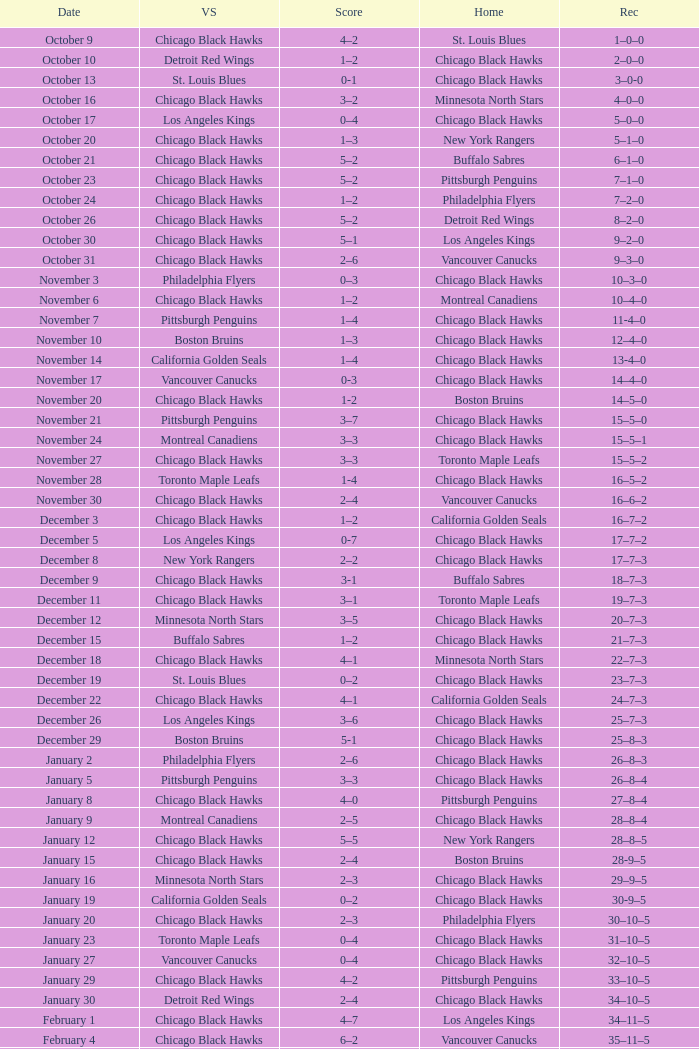What is the Record from February 10? 36–13–5. Help me parse the entirety of this table. {'header': ['Date', 'VS', 'Score', 'Home', 'Rec'], 'rows': [['October 9', 'Chicago Black Hawks', '4–2', 'St. Louis Blues', '1–0–0'], ['October 10', 'Detroit Red Wings', '1–2', 'Chicago Black Hawks', '2–0–0'], ['October 13', 'St. Louis Blues', '0-1', 'Chicago Black Hawks', '3–0-0'], ['October 16', 'Chicago Black Hawks', '3–2', 'Minnesota North Stars', '4–0–0'], ['October 17', 'Los Angeles Kings', '0–4', 'Chicago Black Hawks', '5–0–0'], ['October 20', 'Chicago Black Hawks', '1–3', 'New York Rangers', '5–1–0'], ['October 21', 'Chicago Black Hawks', '5–2', 'Buffalo Sabres', '6–1–0'], ['October 23', 'Chicago Black Hawks', '5–2', 'Pittsburgh Penguins', '7–1–0'], ['October 24', 'Chicago Black Hawks', '1–2', 'Philadelphia Flyers', '7–2–0'], ['October 26', 'Chicago Black Hawks', '5–2', 'Detroit Red Wings', '8–2–0'], ['October 30', 'Chicago Black Hawks', '5–1', 'Los Angeles Kings', '9–2–0'], ['October 31', 'Chicago Black Hawks', '2–6', 'Vancouver Canucks', '9–3–0'], ['November 3', 'Philadelphia Flyers', '0–3', 'Chicago Black Hawks', '10–3–0'], ['November 6', 'Chicago Black Hawks', '1–2', 'Montreal Canadiens', '10–4–0'], ['November 7', 'Pittsburgh Penguins', '1–4', 'Chicago Black Hawks', '11-4–0'], ['November 10', 'Boston Bruins', '1–3', 'Chicago Black Hawks', '12–4–0'], ['November 14', 'California Golden Seals', '1–4', 'Chicago Black Hawks', '13-4–0'], ['November 17', 'Vancouver Canucks', '0-3', 'Chicago Black Hawks', '14–4–0'], ['November 20', 'Chicago Black Hawks', '1-2', 'Boston Bruins', '14–5–0'], ['November 21', 'Pittsburgh Penguins', '3–7', 'Chicago Black Hawks', '15–5–0'], ['November 24', 'Montreal Canadiens', '3–3', 'Chicago Black Hawks', '15–5–1'], ['November 27', 'Chicago Black Hawks', '3–3', 'Toronto Maple Leafs', '15–5–2'], ['November 28', 'Toronto Maple Leafs', '1-4', 'Chicago Black Hawks', '16–5–2'], ['November 30', 'Chicago Black Hawks', '2–4', 'Vancouver Canucks', '16–6–2'], ['December 3', 'Chicago Black Hawks', '1–2', 'California Golden Seals', '16–7–2'], ['December 5', 'Los Angeles Kings', '0-7', 'Chicago Black Hawks', '17–7–2'], ['December 8', 'New York Rangers', '2–2', 'Chicago Black Hawks', '17–7–3'], ['December 9', 'Chicago Black Hawks', '3-1', 'Buffalo Sabres', '18–7–3'], ['December 11', 'Chicago Black Hawks', '3–1', 'Toronto Maple Leafs', '19–7–3'], ['December 12', 'Minnesota North Stars', '3–5', 'Chicago Black Hawks', '20–7–3'], ['December 15', 'Buffalo Sabres', '1–2', 'Chicago Black Hawks', '21–7–3'], ['December 18', 'Chicago Black Hawks', '4–1', 'Minnesota North Stars', '22–7–3'], ['December 19', 'St. Louis Blues', '0–2', 'Chicago Black Hawks', '23–7–3'], ['December 22', 'Chicago Black Hawks', '4–1', 'California Golden Seals', '24–7–3'], ['December 26', 'Los Angeles Kings', '3–6', 'Chicago Black Hawks', '25–7–3'], ['December 29', 'Boston Bruins', '5-1', 'Chicago Black Hawks', '25–8–3'], ['January 2', 'Philadelphia Flyers', '2–6', 'Chicago Black Hawks', '26–8–3'], ['January 5', 'Pittsburgh Penguins', '3–3', 'Chicago Black Hawks', '26–8–4'], ['January 8', 'Chicago Black Hawks', '4–0', 'Pittsburgh Penguins', '27–8–4'], ['January 9', 'Montreal Canadiens', '2–5', 'Chicago Black Hawks', '28–8–4'], ['January 12', 'Chicago Black Hawks', '5–5', 'New York Rangers', '28–8–5'], ['January 15', 'Chicago Black Hawks', '2–4', 'Boston Bruins', '28-9–5'], ['January 16', 'Minnesota North Stars', '2–3', 'Chicago Black Hawks', '29–9–5'], ['January 19', 'California Golden Seals', '0–2', 'Chicago Black Hawks', '30-9–5'], ['January 20', 'Chicago Black Hawks', '2–3', 'Philadelphia Flyers', '30–10–5'], ['January 23', 'Toronto Maple Leafs', '0–4', 'Chicago Black Hawks', '31–10–5'], ['January 27', 'Vancouver Canucks', '0–4', 'Chicago Black Hawks', '32–10–5'], ['January 29', 'Chicago Black Hawks', '4–2', 'Pittsburgh Penguins', '33–10–5'], ['January 30', 'Detroit Red Wings', '2–4', 'Chicago Black Hawks', '34–10–5'], ['February 1', 'Chicago Black Hawks', '4–7', 'Los Angeles Kings', '34–11–5'], ['February 4', 'Chicago Black Hawks', '6–2', 'Vancouver Canucks', '35–11–5'], ['February 6', 'Minnesota North Stars', '0–5', 'Chicago Black Hawks', '36–11–5'], ['February 9', 'Chicago Black Hawks', '1–4', 'New York Rangers', '36–12–5'], ['February 10', 'Chicago Black Hawks', '1–7', 'Montreal Canadiens', '36–13–5'], ['February 12', 'Chicago Black Hawks', '3-3', 'Detroit Red Wings', '36–13–6'], ['February 13', 'Toronto Maple Leafs', '1–3', 'Chicago Black Hawks', '37–13–6'], ['February 15', 'Chicago Black Hawks', '3–2', 'St. Louis Blues', '38–13–6'], ['February 16', 'Philadelphia Flyers', '3–3', 'Chicago Black Hawks', '38–13–7'], ['February 20', 'Boston Bruins', '3–1', 'Chicago Black Hawks', '38–14–7'], ['February 23', 'Buffalo Sabres', '2–1', 'Chicago Black Hawks', '38–15–7'], ['February 24', 'Chicago Black Hawks', '3–5', 'Buffalo Sabres', '38–16–7'], ['February 26', 'California Golden Seals', '0–3', 'Chicago Black Hawks', '39–16–7'], ['February 27', 'Vancouver Canucks', '3–3', 'Chicago Black Hawks', '39–16–8'], ['March 1', 'Chicago Black Hawks', '6–4', 'Los Angeles Kings', '40–16–8'], ['March 3', 'Chicago Black Hawks', '4-4', 'California Golden Seals', '40–16–9'], ['March 5', 'Chicago Black Hawks', '1–2', 'Minnesota North Stars', '40–17–9'], ['March 8', 'Chicago Black Hawks', '3–3', 'New York Rangers', '40–17–10'], ['March 11', 'Chicago Black Hawks', '1–1', 'Montreal Canadiens', '40–17–11'], ['March 12', 'Chicago Black Hawks', '3–2', 'Detroit Red Wings', '41–17–11'], ['March 15', 'New York Rangers', '1–3', 'Chicago Black Hawks', '42–17–11'], ['March 18', 'Chicago Black Hawks', '2–2', 'Toronto Maple Leafs', '42–17–12'], ['March 19', 'Buffalo Sabres', '3–3', 'Chicago Black Hawks', '42–17-13'], ['March 23', 'Chicago Black Hawks', '4–2', 'Philadelphia Flyers', '43–17–13'], ['March 25', 'Chicago Black Hawks', '5–5', 'Boston Bruins', '43–17–14'], ['March 26', 'St. Louis Blues', '0–4', 'Chicago Black Hawks', '44–17–14'], ['March 29', 'Montreal Canadiens', '5–5', 'Chicago Black Hawks', '44–17–15'], ['April 1', 'Chicago Black Hawks', '2–0', 'St. Louis Blues', '45–17–15'], ['April 2', 'Detroit Red Wings', '1–6', 'Chicago Black Hawks', '46-17–15']]} 